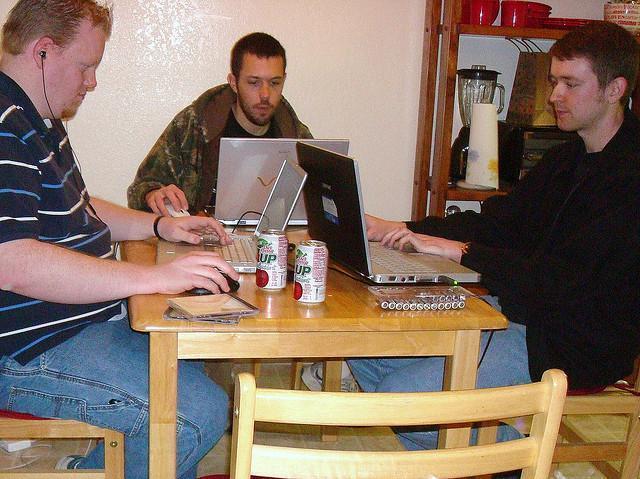Why are they all there together?
From the following four choices, select the correct answer to address the question.
Options: Hiding, fighting, eating lunch, sharing table. Sharing table. 